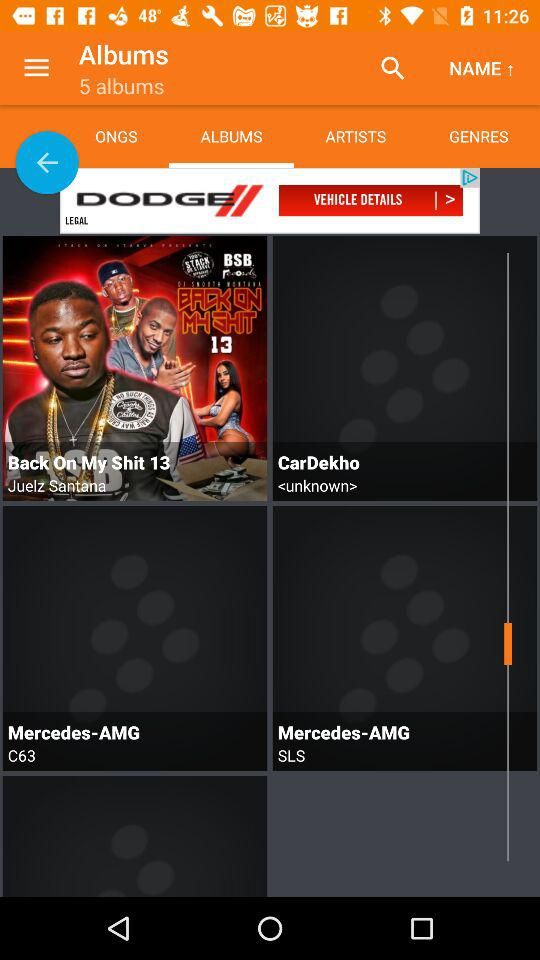Who is the singer of "Back On My Shit 13"? The singer is Juelz Santana. 